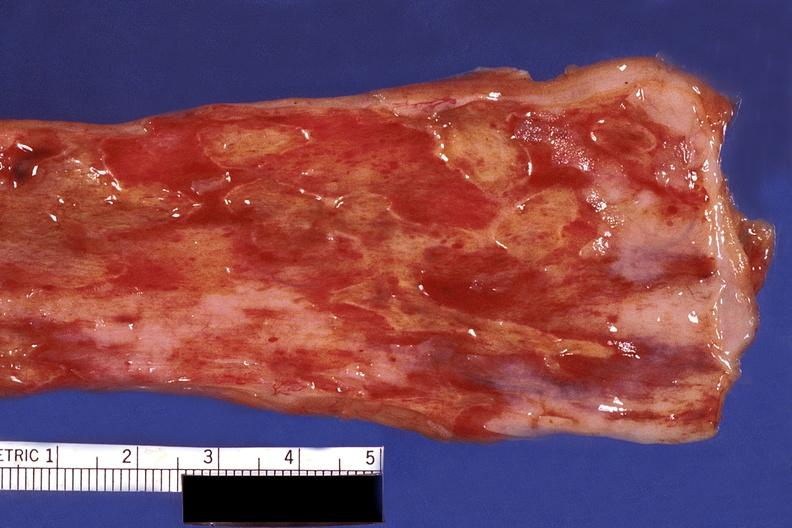s gastrointestinal present?
Answer the question using a single word or phrase. Yes 